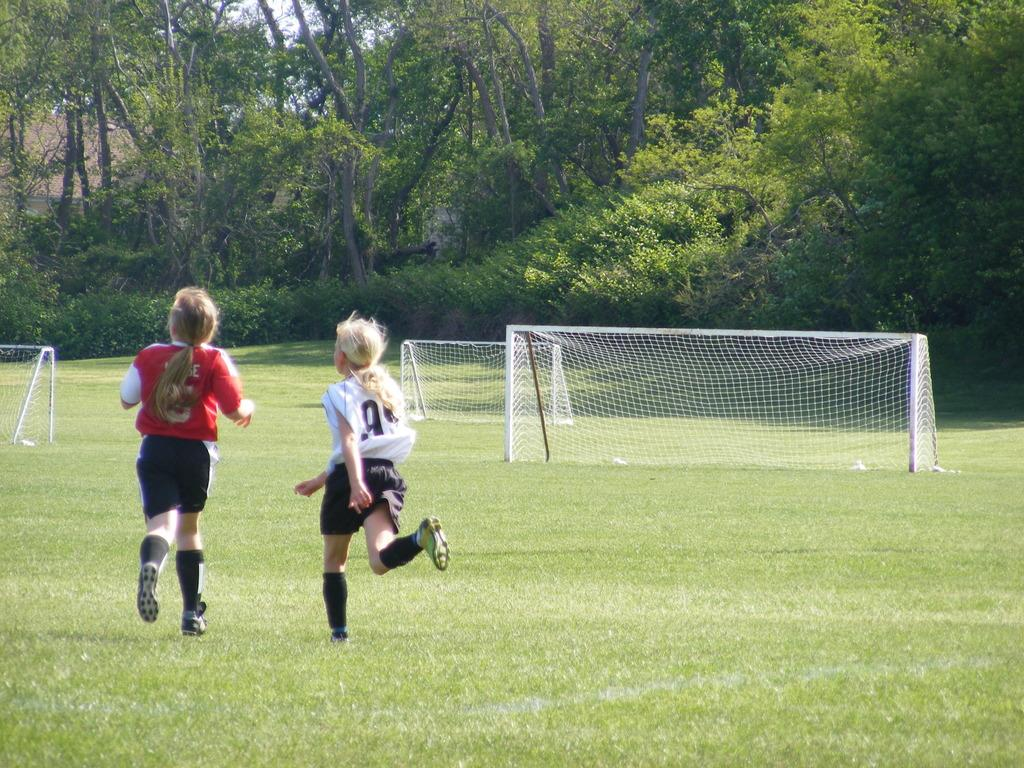What are the people in the image wearing? The people in the image are wearing T-shirts and shorts. What can be seen on the ground in the image? The ground is visible in the image and has some grass. What structures are present in the image? There are nets in the image. What type of vegetation can be seen in the image? There are trees and plants in the image. What is visible in the background of the image? The sky is visible in the image. What type of grain is being harvested in the image? There is no grain present in the image; it features people wearing T-shirts and shorts, trees, and plants. 